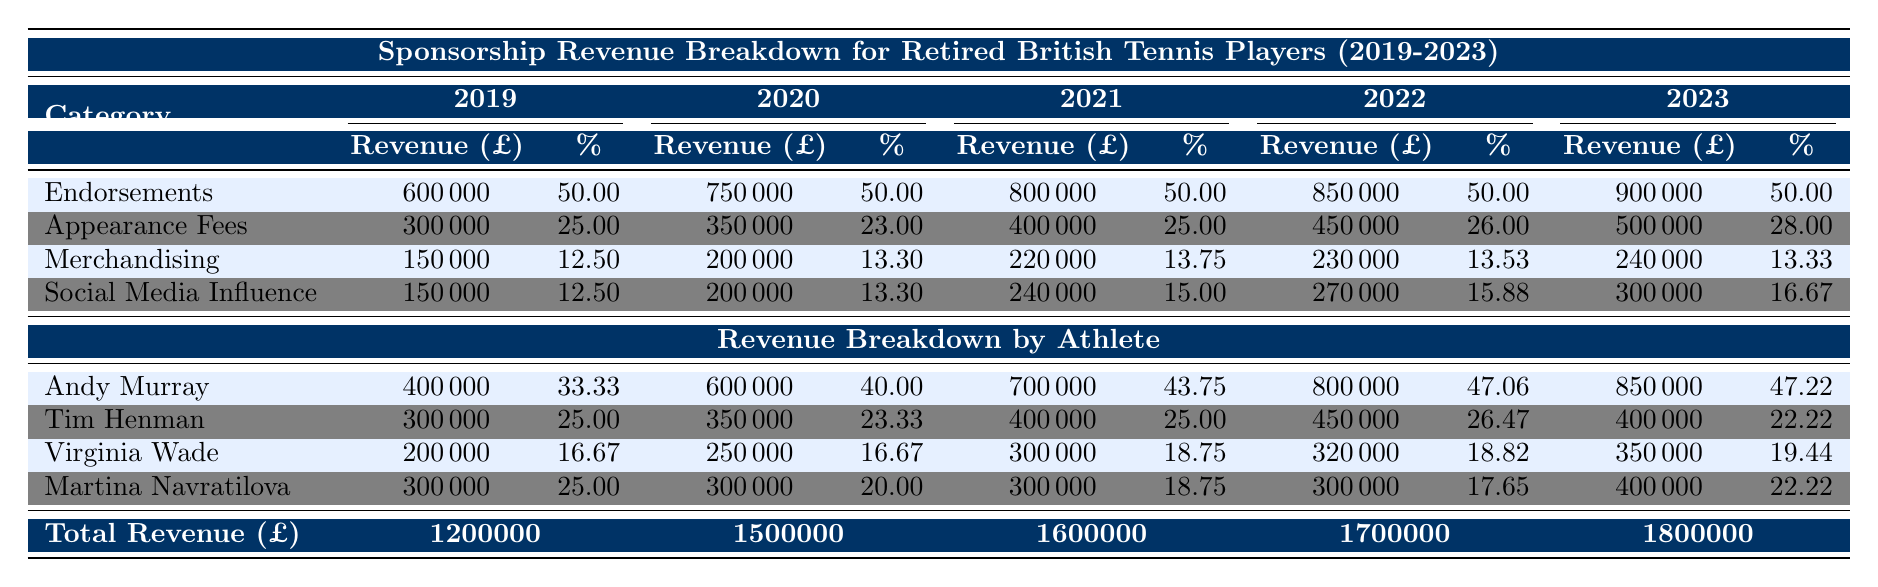What's the total sponsorship revenue in 2023? From the "Overview" section of the table, the total revenue for the year 2023 is directly listed as 1,800,000.
Answer: 1,800,000 Which category of sponsorship generated the most revenue in 2021? In 2021, the category with the highest revenue can be found by comparing the "Revenue (£)" figures. Endorsements led with 800,000, while Appearance Fees, Merchandising, and Social Media Influence had lower revenues, confirming Endorsements as the highest.
Answer: Endorsements What percentage of total revenue did Appearance Fees represent in 2020? For 2020, the "Percentage of Total (%)" for Appearance Fees is recorded as 23.00%, which directly indicates their share of the total sponsorship revenue for that year.
Answer: 23.00% Calculate the average merchandising revenue over the five years. To find the average, sum the merchandising revenue from each year: 150,000 + 200,000 + 220,000 + 230,000 + 240,000 = 1,040,000. There are 5 years, so divide this total by 5, giving an average of 208,000.
Answer: 208,000 Did Tim Henman's total revenue ever exceed 400,000 across the five years? Looking at Tim Henman's total revenue for each year, it shows he reached exactly 400,000 in 2021 and 2023 but did not exceed it in any of the five years, as confirmed by the provided values.
Answer: No What is the total revenue from Social Media Influence in 2022 and 2023? The revenue from Social Media Influence for 2022 is listed as 270,000, and for 2023 it is 300,000. Adding these two amounts gives 270,000 + 300,000 = 570,000.
Answer: 570,000 Which athlete had the highest percentage of total revenue in 2022? In 2022, the percentages of total revenue for each athlete are: Andy Murray (47.06%), Tim Henman (26.47%), Virginia Wade (18.82%), and Martina Navratilova (17.65%). Andy Murray has the highest percentage.
Answer: Andy Murray What is the trend in total sponsorship revenue from 2019 to 2023? By observing the "Total Revenue (£)" over these years: 1,200,000 in 2019 rises to 1,800,000 in 2023. The trend shows consistent growth in total revenue each year.
Answer: Increasing How much revenue from Endorsements did Andy Murray earn in 2021? In 2021, the total revenue from Endorsements for Andy Murray was recorded as 700,000, which indicates his earnings from that category for that year.
Answer: 700,000 What was the change in Virginia Wade's revenue from 2021 to 2023? Virginia Wade's revenue was 300,000 in 2021 and increased to 350,000 in 2023. The change can be calculated as 350,000 - 300,000 = 50,000.
Answer: 50,000 Which sponsorship category has the most stable percentage across the five years? Evaluating the percentage values for each category shows that Endorsements consistently maintained a percentage of 50% each year, indicating stability compared to the other categories with fluctuating percentages.
Answer: Endorsements 